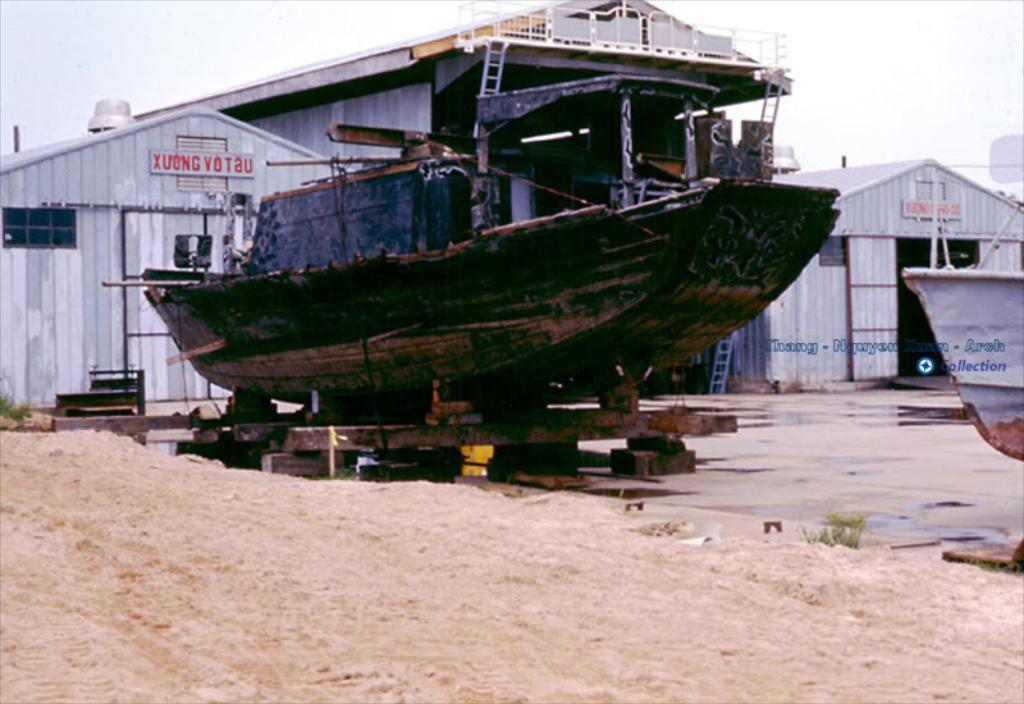What type of vehicles can be seen in the image? There are boats in the image. What type of terrain is visible in the image? There is sand and grass visible in the image. What object can be used for climbing in the image? There is a ladder in the image. What type of structures are present in the image? There are houses in the image. What signage can be seen in the image? There are name boards in the image. What is visible in the background of the image? The sky is visible in the background of the image. What type of lock is used to secure the hole in the image? There is no lock or hole present in the image. What committee is responsible for managing the boats in the image? There is no committee mentioned or implied in the image. 